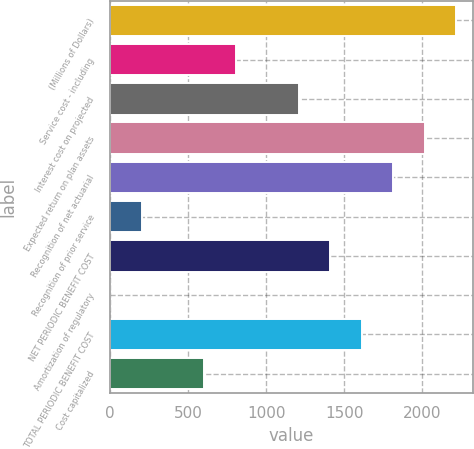Convert chart to OTSL. <chart><loc_0><loc_0><loc_500><loc_500><bar_chart><fcel>(Millions of Dollars)<fcel>Service cost - including<fcel>Interest cost on projected<fcel>Expected return on plan assets<fcel>Recognition of net actuarial<fcel>Recognition of prior service<fcel>NET PERIODIC BENEFIT COST<fcel>Amortization of regulatory<fcel>TOTAL PERIODIC BENEFIT COST<fcel>Cost capitalized<nl><fcel>2215.2<fcel>806.8<fcel>1209.2<fcel>2014<fcel>1812.8<fcel>203.2<fcel>1410.4<fcel>2<fcel>1611.6<fcel>605.6<nl></chart> 